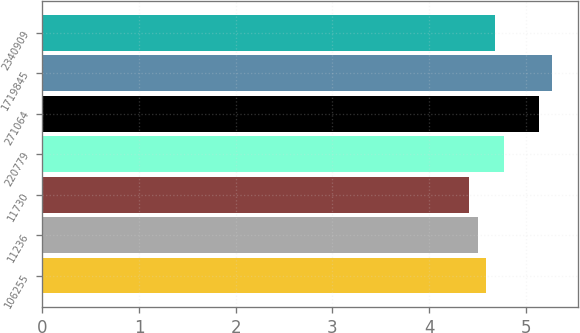Convert chart to OTSL. <chart><loc_0><loc_0><loc_500><loc_500><bar_chart><fcel>106255<fcel>11236<fcel>11730<fcel>220779<fcel>271064<fcel>1719845<fcel>2340909<nl><fcel>4.59<fcel>4.5<fcel>4.41<fcel>4.77<fcel>5.13<fcel>5.27<fcel>4.68<nl></chart> 